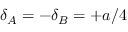<formula> <loc_0><loc_0><loc_500><loc_500>\delta _ { A } = - \delta _ { B } = + a / 4</formula> 